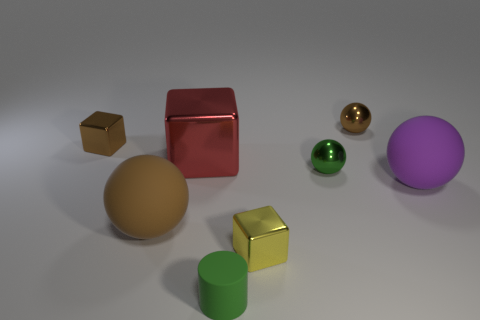Is there anything else that is the same material as the purple thing?
Your answer should be very brief. Yes. There is a thing that is to the right of the tiny green ball and in front of the small brown sphere; what material is it?
Provide a short and direct response. Rubber. What is the shape of the green object that is the same material as the small yellow cube?
Your answer should be very brief. Sphere. Are there any other things that have the same color as the large cube?
Provide a short and direct response. No. Is the number of cylinders on the right side of the small green matte cylinder greater than the number of tiny cubes?
Offer a very short reply. No. What material is the green cylinder?
Provide a succinct answer. Rubber. How many matte balls are the same size as the purple matte thing?
Provide a succinct answer. 1. Are there the same number of yellow cubes that are behind the green metal thing and purple rubber balls that are in front of the purple thing?
Your answer should be compact. Yes. Does the yellow object have the same material as the big brown ball?
Provide a succinct answer. No. Is there a brown matte ball behind the purple matte sphere that is right of the matte cylinder?
Ensure brevity in your answer.  No. 